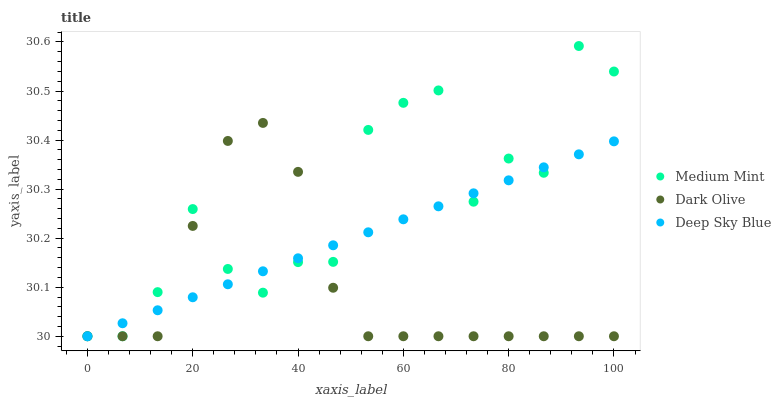Does Dark Olive have the minimum area under the curve?
Answer yes or no. Yes. Does Medium Mint have the maximum area under the curve?
Answer yes or no. Yes. Does Deep Sky Blue have the minimum area under the curve?
Answer yes or no. No. Does Deep Sky Blue have the maximum area under the curve?
Answer yes or no. No. Is Deep Sky Blue the smoothest?
Answer yes or no. Yes. Is Medium Mint the roughest?
Answer yes or no. Yes. Is Dark Olive the smoothest?
Answer yes or no. No. Is Dark Olive the roughest?
Answer yes or no. No. Does Medium Mint have the lowest value?
Answer yes or no. Yes. Does Medium Mint have the highest value?
Answer yes or no. Yes. Does Dark Olive have the highest value?
Answer yes or no. No. Does Deep Sky Blue intersect Dark Olive?
Answer yes or no. Yes. Is Deep Sky Blue less than Dark Olive?
Answer yes or no. No. Is Deep Sky Blue greater than Dark Olive?
Answer yes or no. No. 